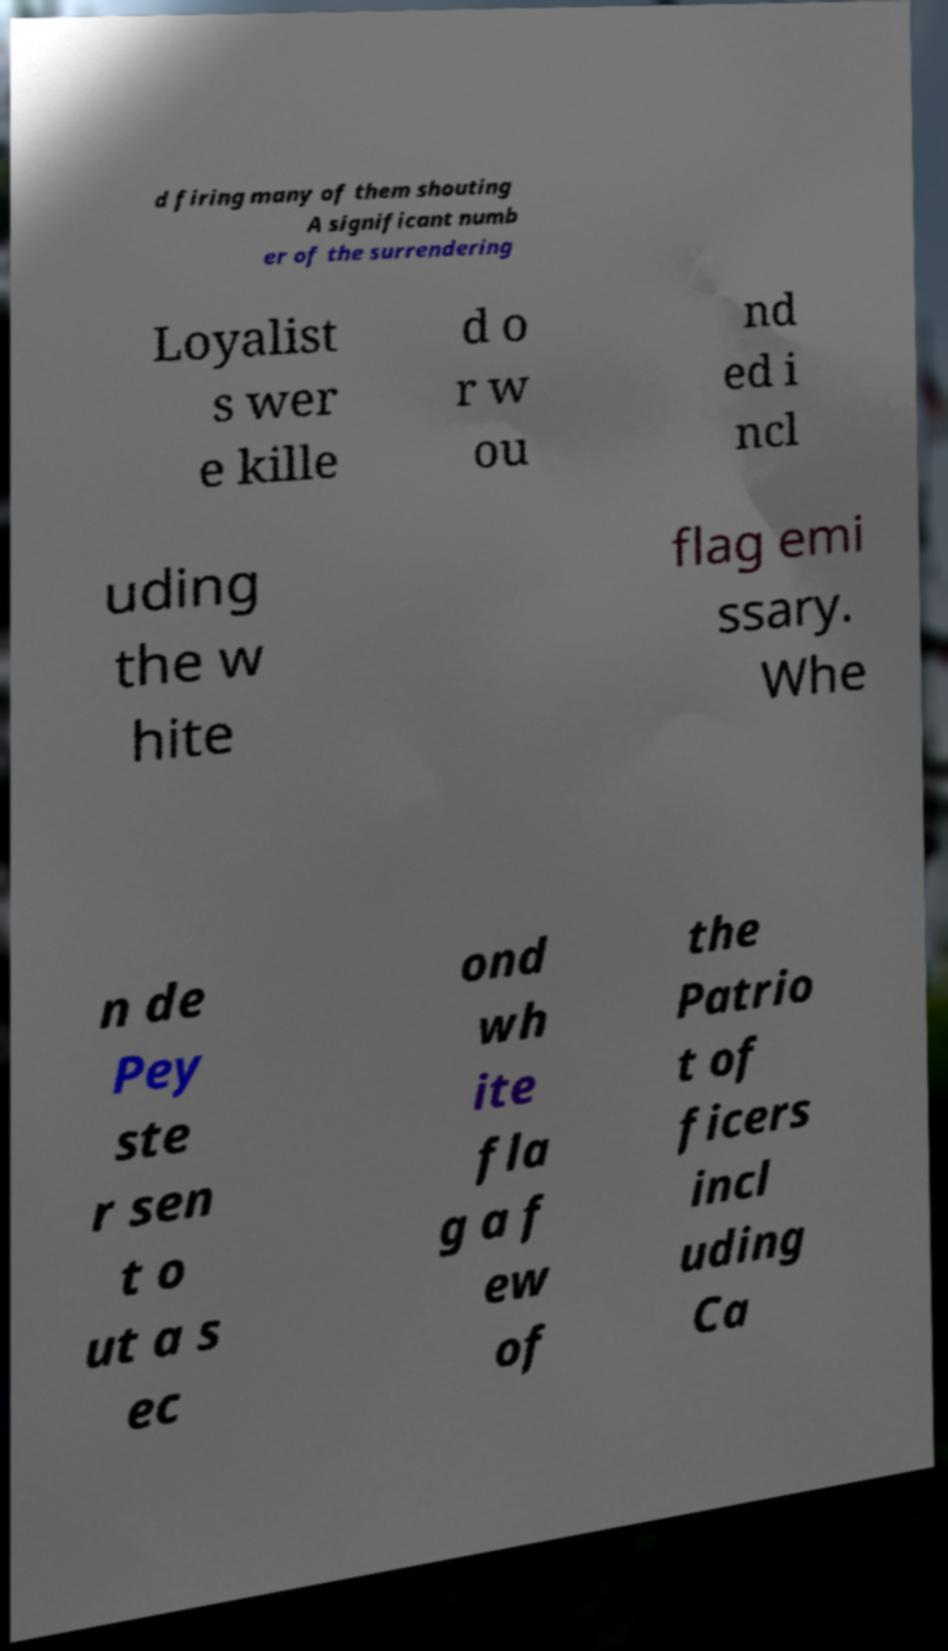Could you assist in decoding the text presented in this image and type it out clearly? d firing many of them shouting A significant numb er of the surrendering Loyalist s wer e kille d o r w ou nd ed i ncl uding the w hite flag emi ssary. Whe n de Pey ste r sen t o ut a s ec ond wh ite fla g a f ew of the Patrio t of ficers incl uding Ca 